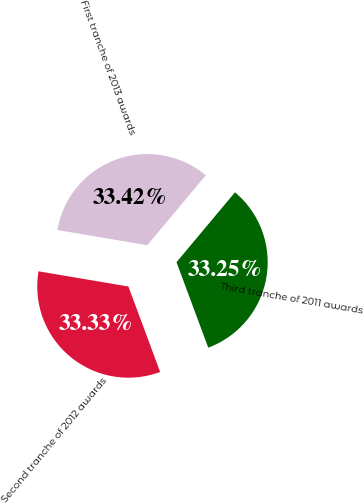Convert chart to OTSL. <chart><loc_0><loc_0><loc_500><loc_500><pie_chart><fcel>Third tranche of 2011 awards<fcel>Second tranche of 2012 awards<fcel>First tranche of 2013 awards<nl><fcel>33.25%<fcel>33.33%<fcel>33.42%<nl></chart> 